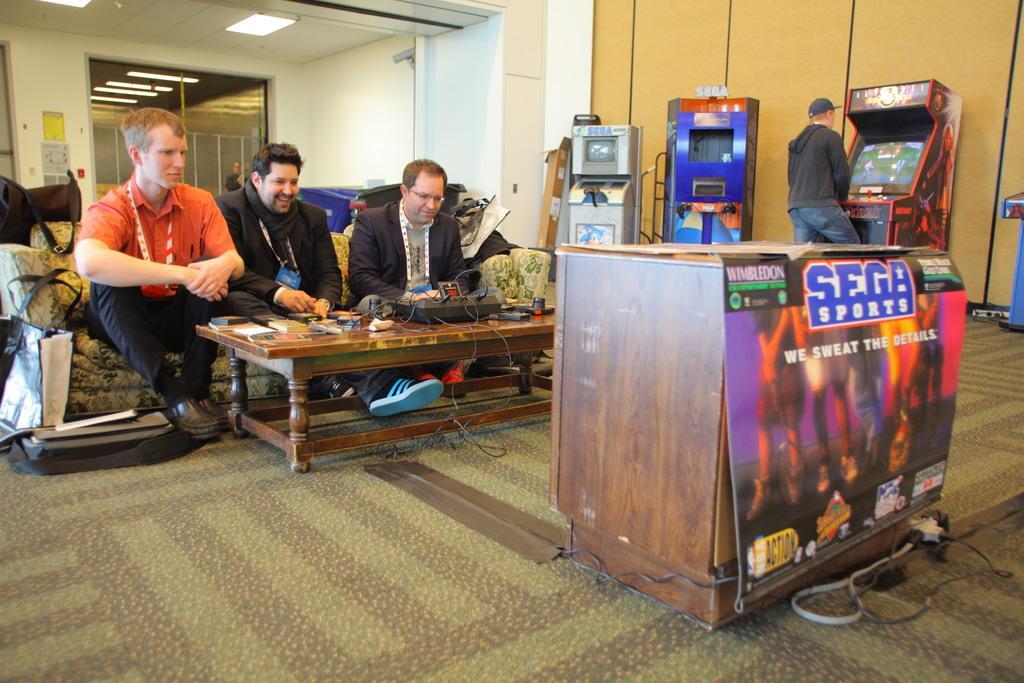In one or two sentences, can you explain what this image depicts? There are three persons sitting on the couch. This is a table with some objects on it. This is the poster attached to the table. I can see another person standing and playing video game. These are the ceiling lights attached to the rooftop. Here are some bags placed on the floor. 